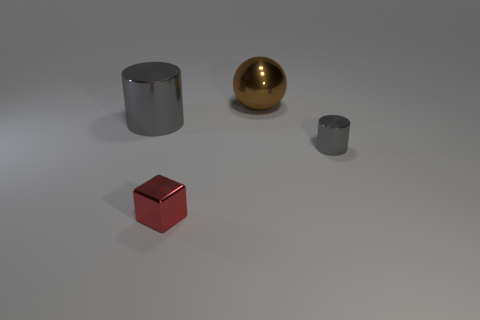How does the texture of the red cube compare to the other objects? The red cube has a distinct texture compared to the other objects. It has a smooth, reflective surface that contrasts with the matte texture of the cylinders. It reflects light more sharply, highlighting its polished look, which indicates it might be made of a different material, perhaps a coated or polished metal. 